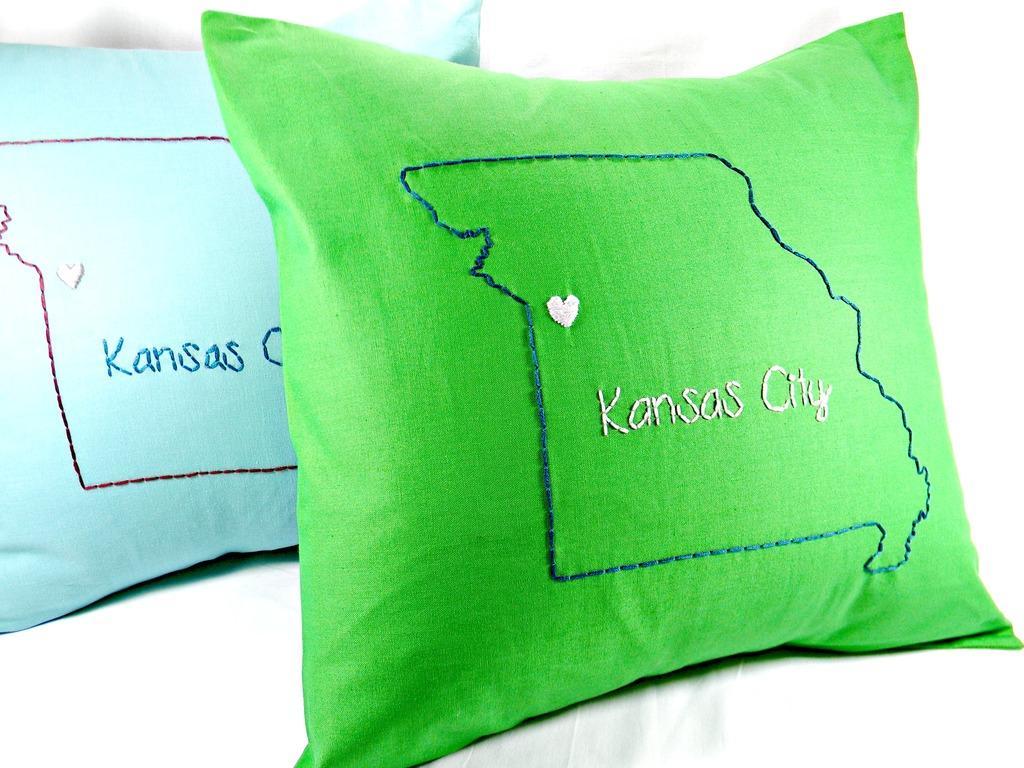Describe this image in one or two sentences. In this picture I can see couple of cushions one is green and another one is blue in color and I can see text on it and a white color background. 